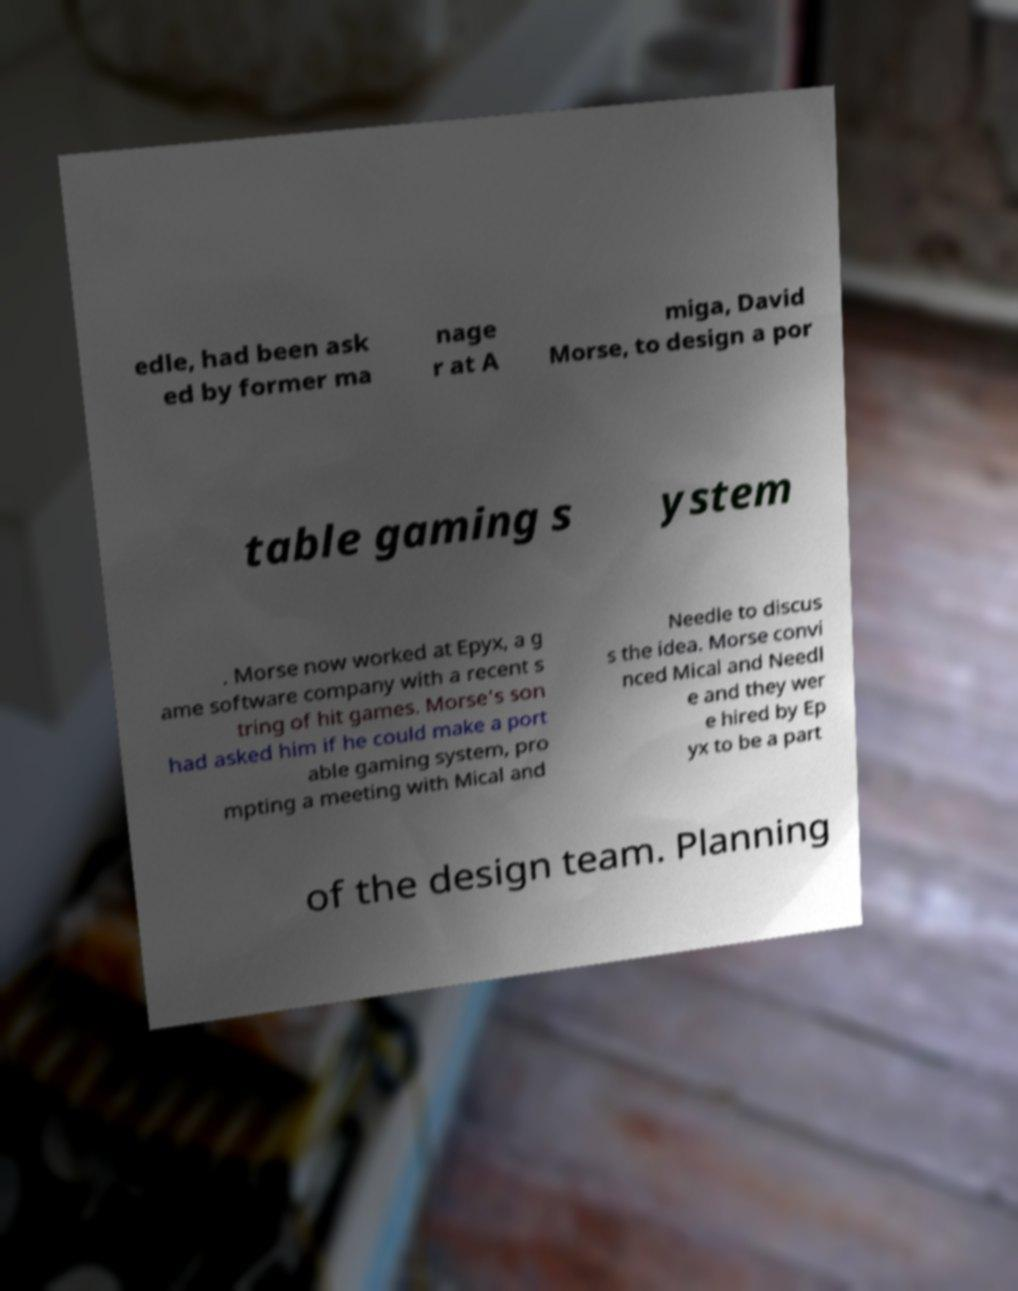Could you assist in decoding the text presented in this image and type it out clearly? edle, had been ask ed by former ma nage r at A miga, David Morse, to design a por table gaming s ystem . Morse now worked at Epyx, a g ame software company with a recent s tring of hit games. Morse's son had asked him if he could make a port able gaming system, pro mpting a meeting with Mical and Needle to discus s the idea. Morse convi nced Mical and Needl e and they wer e hired by Ep yx to be a part of the design team. Planning 